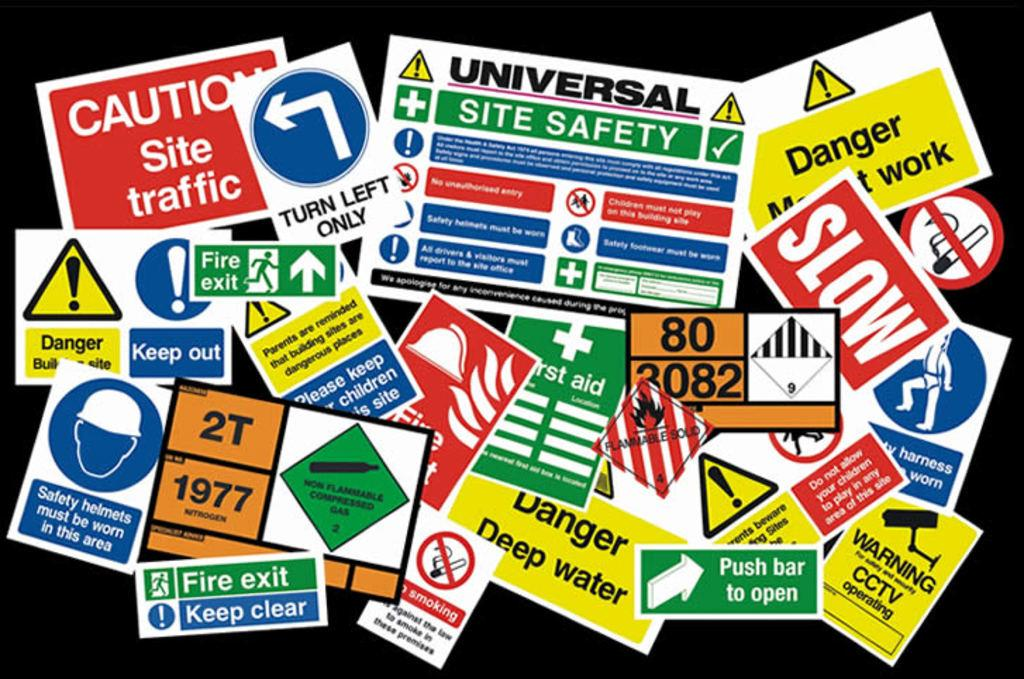<image>
Describe the image concisely. Several safety signs collected on a solid black surface jumbled together. 